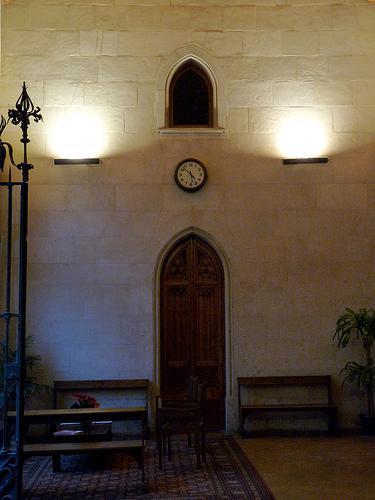How many doors are there?
Give a very brief answer. 1. How many plants are there?
Give a very brief answer. 2. 